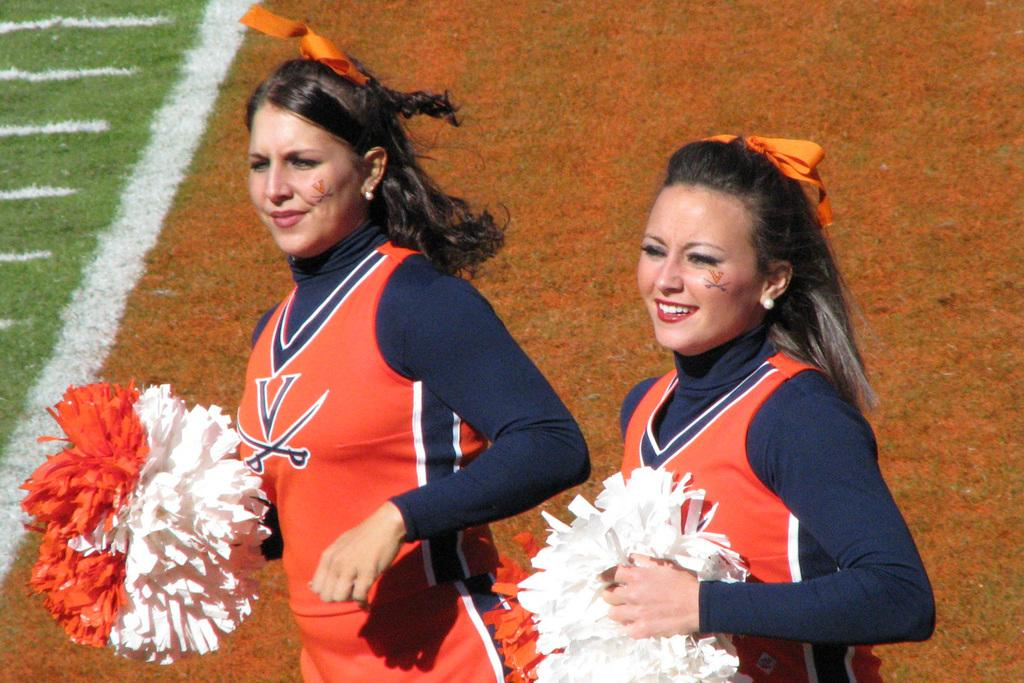How many girls are in the image? There are two girls in the image. What can be said about the appearance of the girls? The girls are beautiful. What are the girls wearing in the image? The girls are wearing orange color t-shirts. What are the girls holding in the image? The girls are holding white and orange color flowers made up of paper. What type of pet do the girls have in the image? There is no pet visible in the image. 